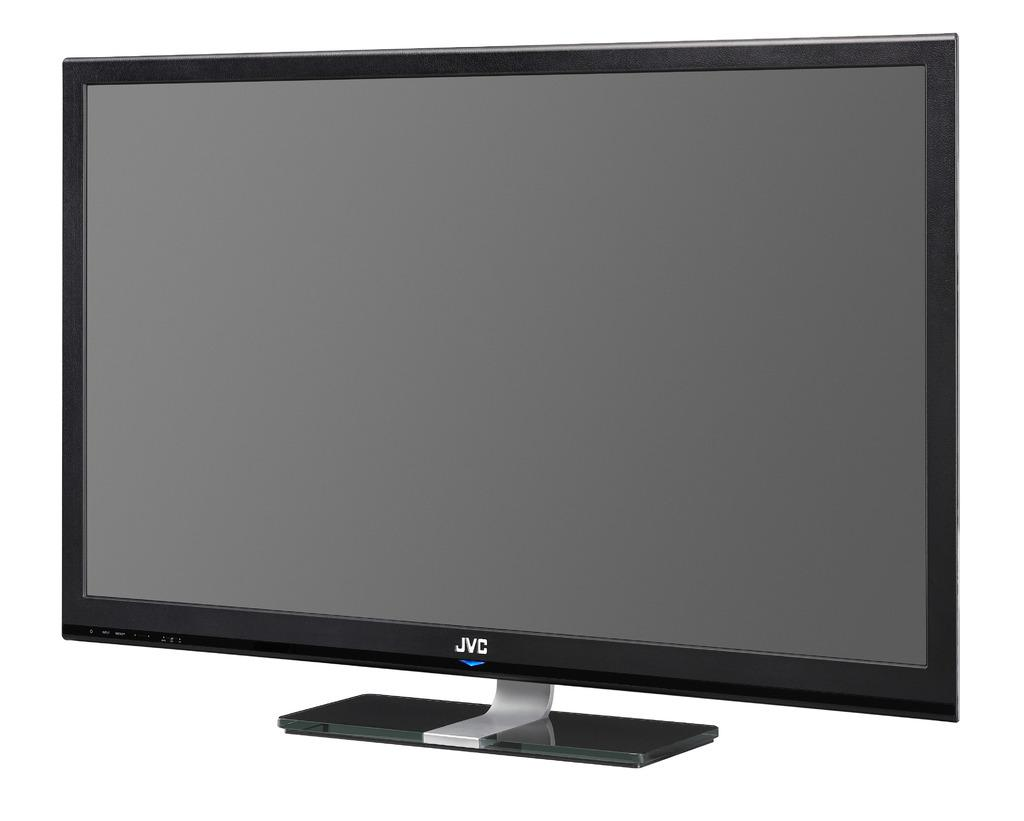Provide a one-sentence caption for the provided image. A black TV says JVC and is on a white background. 